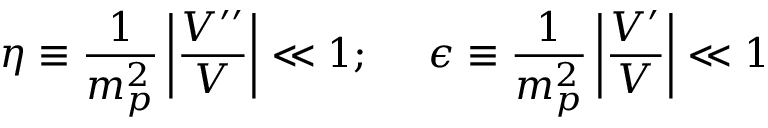<formula> <loc_0><loc_0><loc_500><loc_500>\eta \equiv \frac { 1 } { m _ { p } ^ { 2 } } \left | \frac { V ^ { \prime \prime } } { V } \right | \ll 1 ; \epsilon \equiv \frac { 1 } { m _ { p } ^ { 2 } } \left | \frac { V ^ { \prime } } { V } \right | \ll 1</formula> 